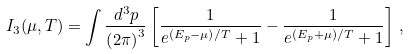Convert formula to latex. <formula><loc_0><loc_0><loc_500><loc_500>I _ { 3 } ( \mu , T ) = \int \frac { d ^ { 3 } p } { \left ( 2 \pi \right ) ^ { 3 } } \left [ \frac { 1 } { e ^ { \left ( E _ { p } - \mu \right ) / T } + 1 } - \frac { 1 } { e ^ { \left ( E _ { p } + \mu \right ) / T } + 1 } \right ] \, ,</formula> 